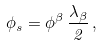<formula> <loc_0><loc_0><loc_500><loc_500>\phi _ { s } = \phi ^ { \beta } \, \frac { \lambda _ { \beta } } { 2 } \, ,</formula> 